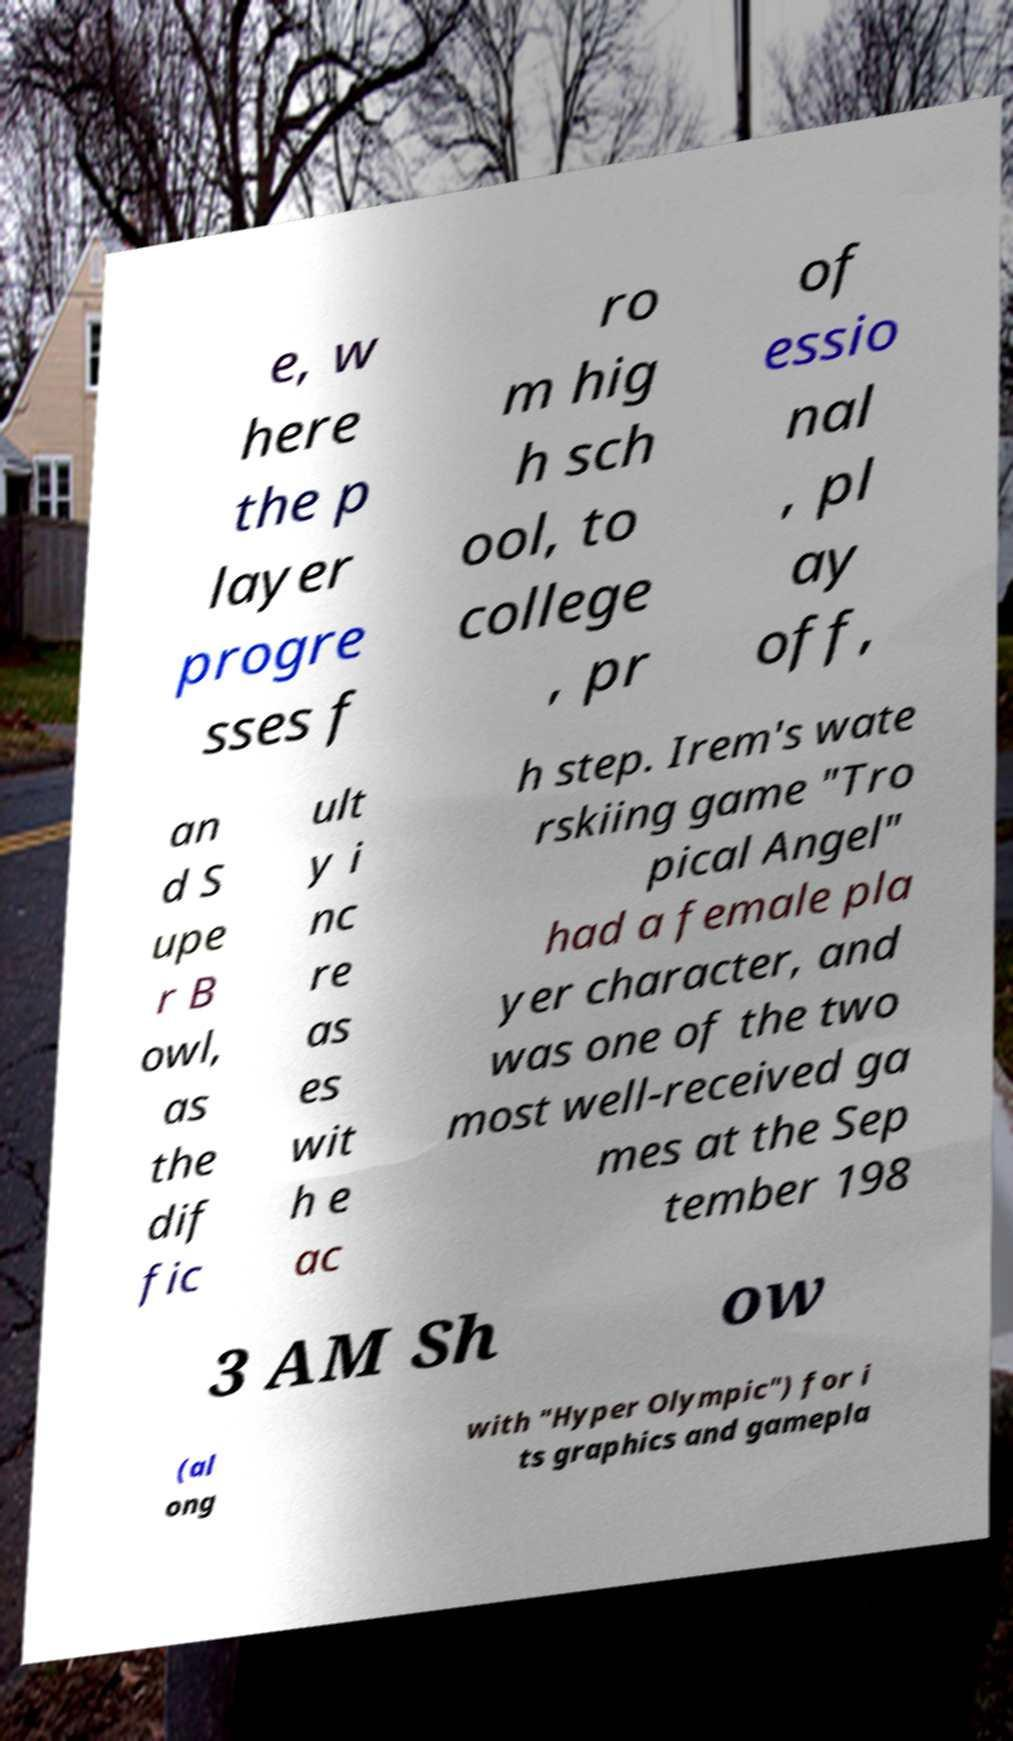Could you assist in decoding the text presented in this image and type it out clearly? e, w here the p layer progre sses f ro m hig h sch ool, to college , pr of essio nal , pl ay off, an d S upe r B owl, as the dif fic ult y i nc re as es wit h e ac h step. Irem's wate rskiing game "Tro pical Angel" had a female pla yer character, and was one of the two most well-received ga mes at the Sep tember 198 3 AM Sh ow (al ong with "Hyper Olympic") for i ts graphics and gamepla 